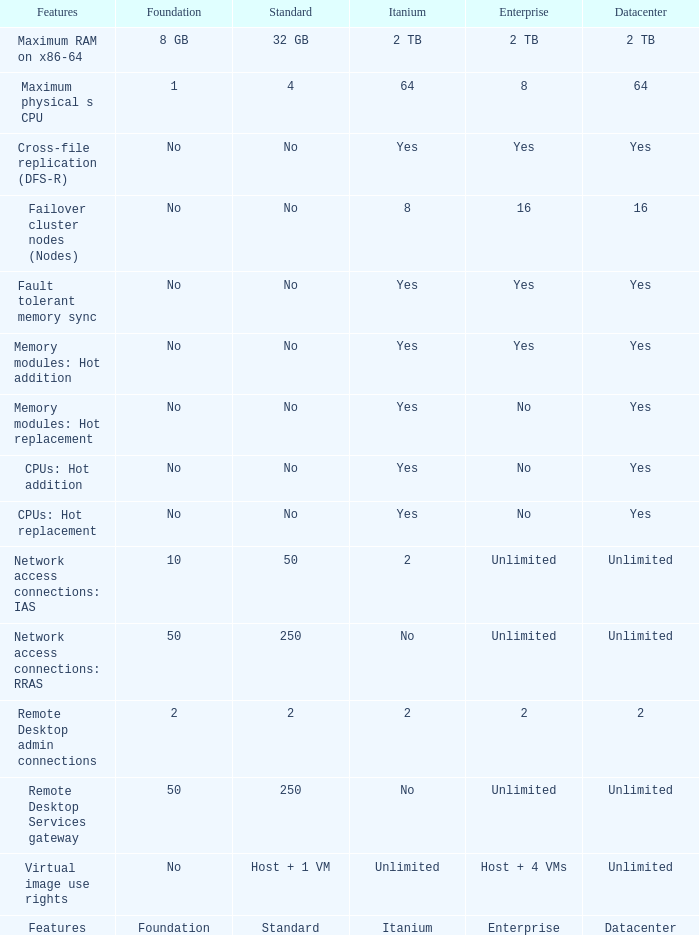Which Features have Yes listed under Datacenter? Cross-file replication (DFS-R), Fault tolerant memory sync, Memory modules: Hot addition, Memory modules: Hot replacement, CPUs: Hot addition, CPUs: Hot replacement. 